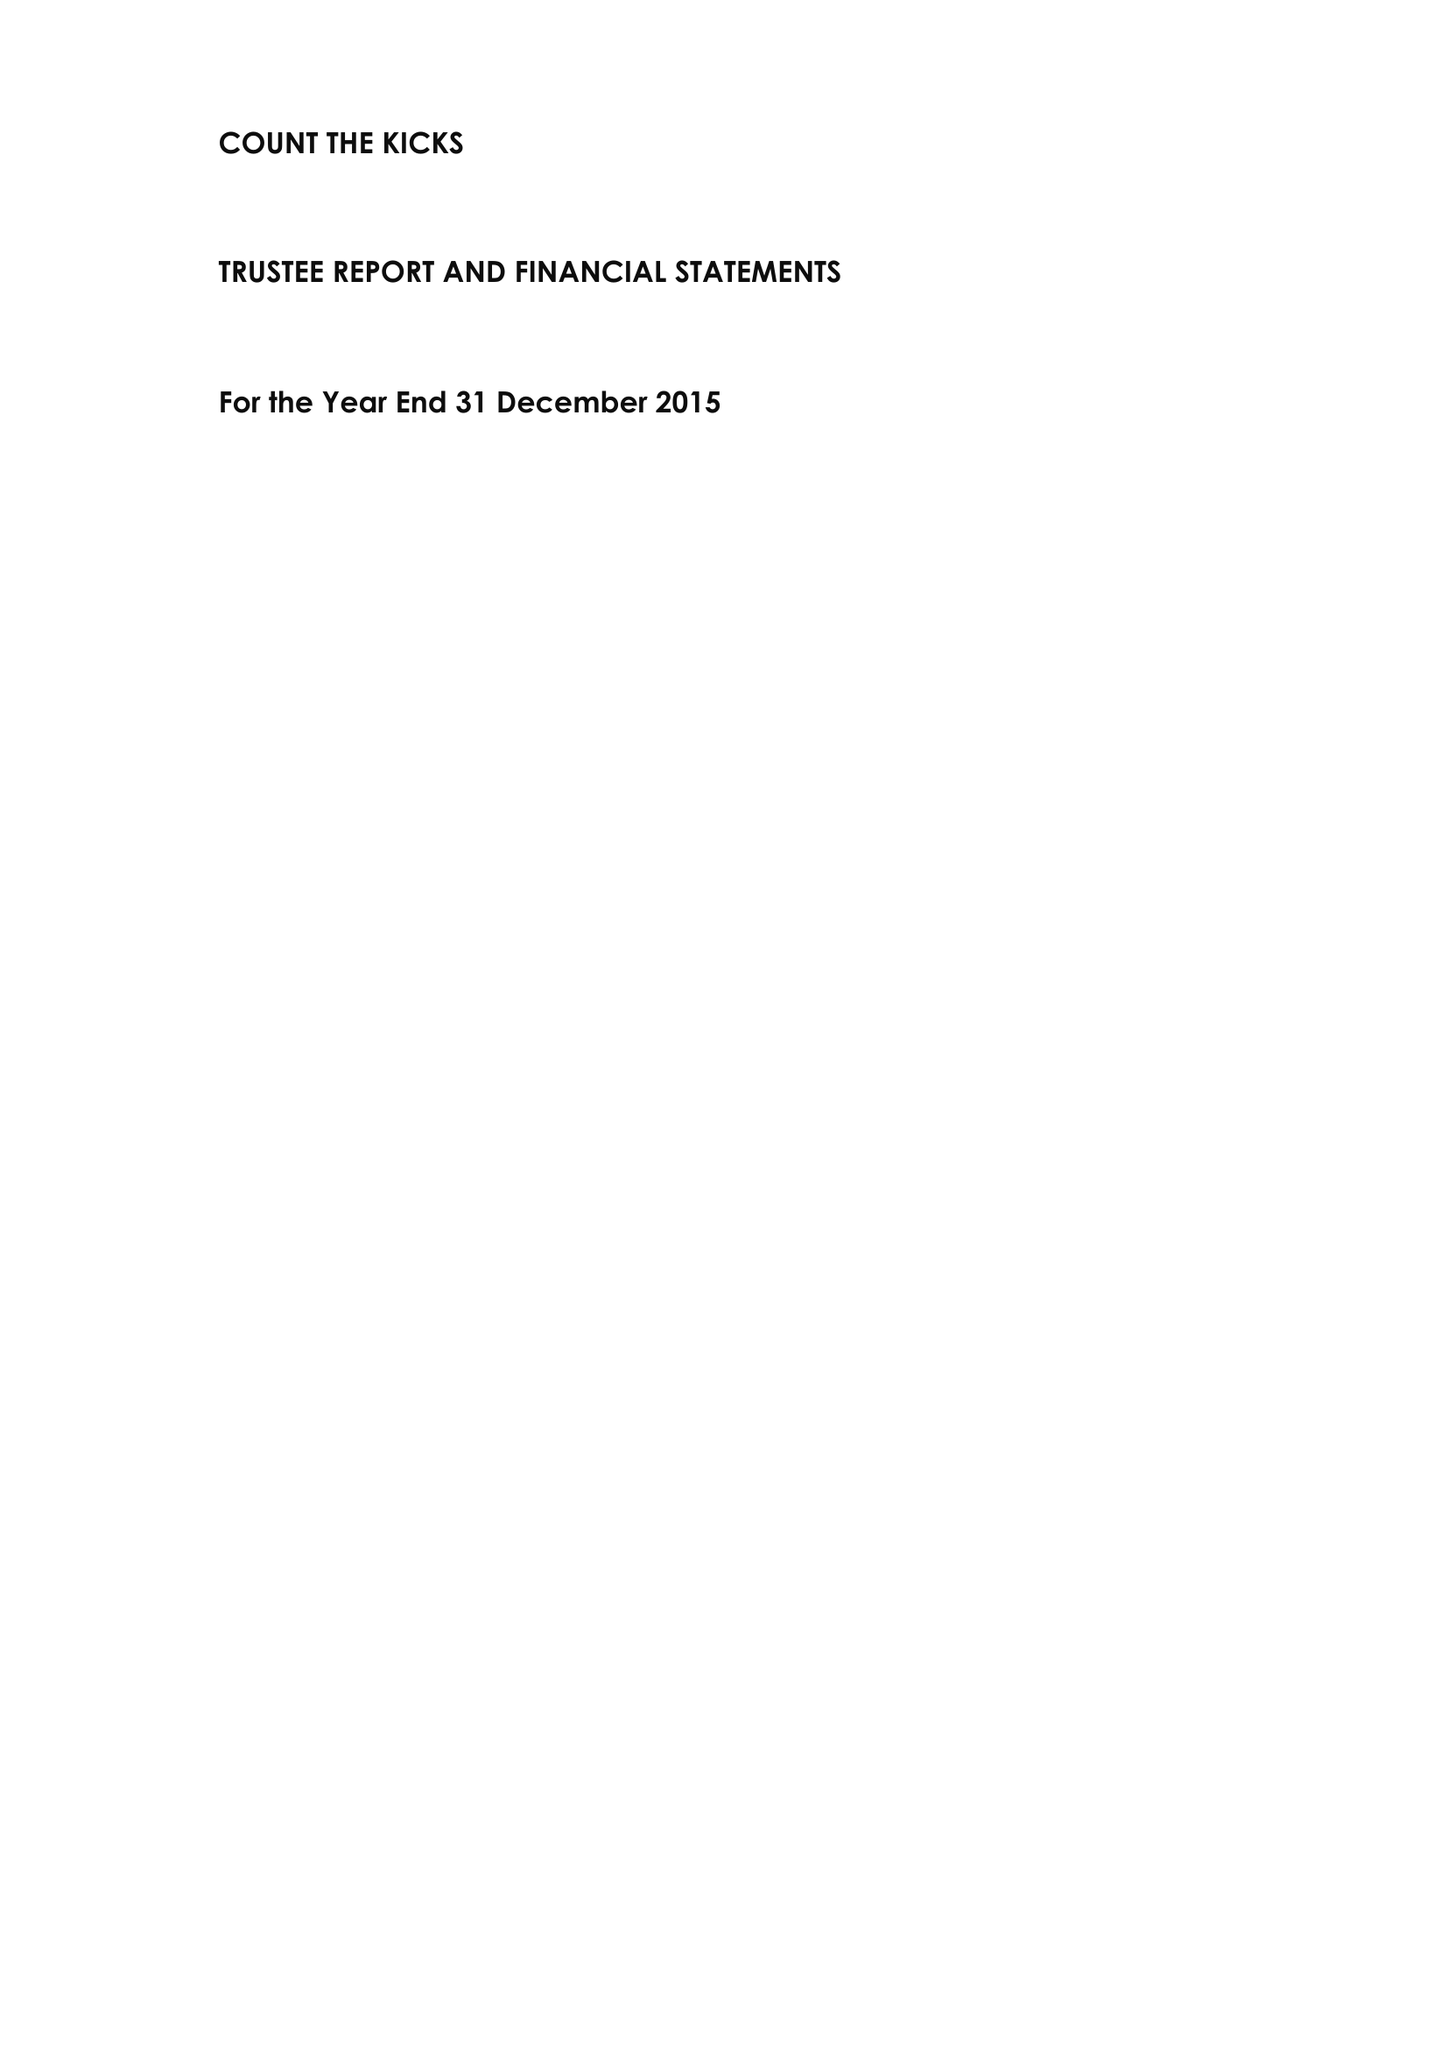What is the value for the charity_number?
Answer the question using a single word or phrase. 1145073 